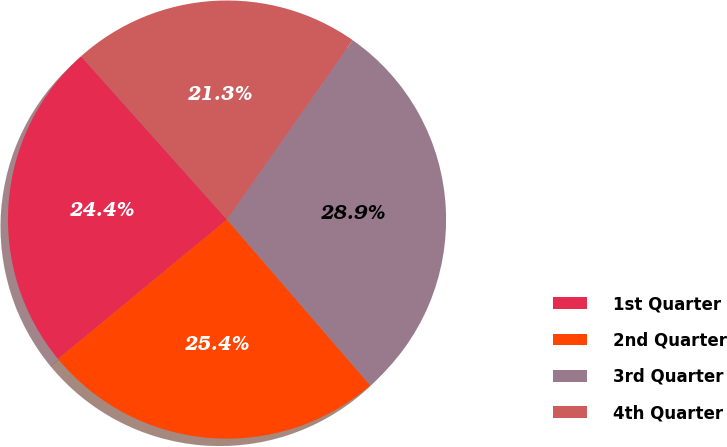Convert chart to OTSL. <chart><loc_0><loc_0><loc_500><loc_500><pie_chart><fcel>1st Quarter<fcel>2nd Quarter<fcel>3rd Quarter<fcel>4th Quarter<nl><fcel>24.37%<fcel>25.36%<fcel>28.94%<fcel>21.33%<nl></chart> 